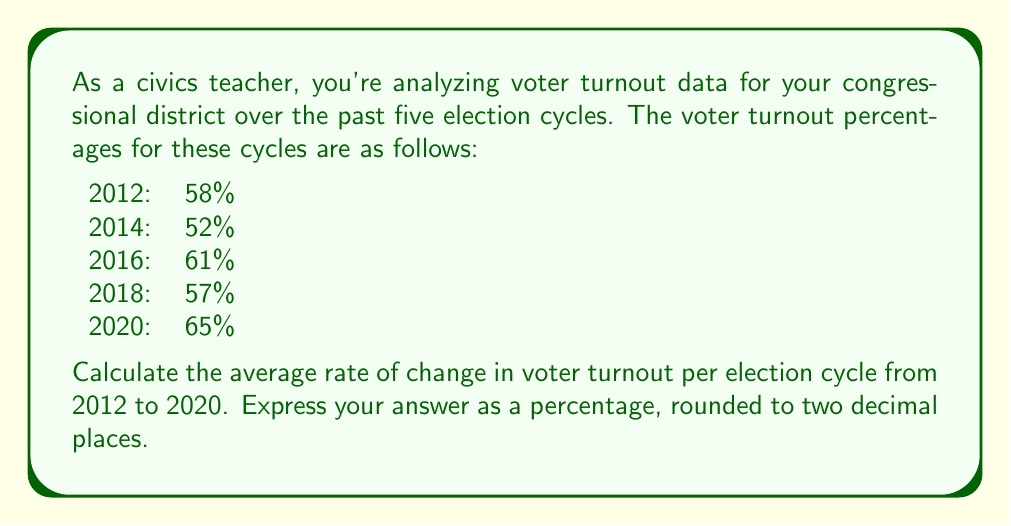Help me with this question. To solve this problem, we'll follow these steps:

1) First, let's define our variables:
   $x$ represents the election cycle number (1 for 2012, 2 for 2014, etc.)
   $y$ represents the voter turnout percentage

2) We need to find the rate of change between the first (2012) and last (2020) data points.

3) The formula for the rate of change is:

   $$\text{Rate of change} = \frac{\text{Change in y}}{\text{Change in x}}$$

4) In this case:
   Initial point $(x_1, y_1)$: (1, 58)
   Final point $(x_5, y_5)$: (5, 65)

5) Plugging into our formula:

   $$\text{Rate of change} = \frac{y_5 - y_1}{x_5 - x_1} = \frac{65 - 58}{5 - 1} = \frac{7}{4} = 1.75$$

6) This means the average increase in voter turnout was 1.75 percentage points per election cycle.

7) To express this as a percentage, we multiply by 100:

   $$1.75 \times 100 = 175\%$$

8) Rounding to two decimal places: 1.75%

This positive rate of change indicates an overall upward trend in voter turnout over these election cycles, despite some fluctuations between individual elections.
Answer: 1.75% 